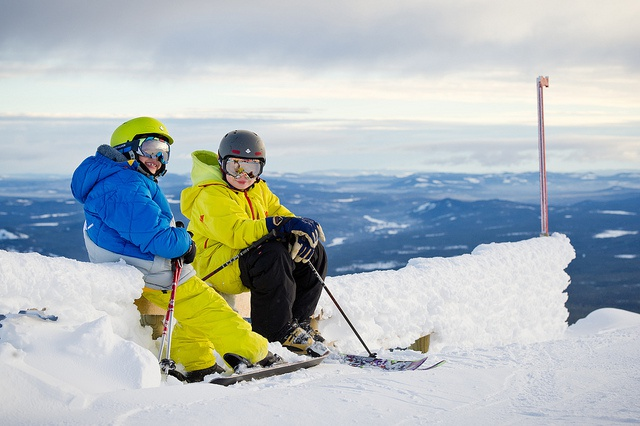Describe the objects in this image and their specific colors. I can see people in gray, blue, olive, gold, and darkgray tones, people in gray, black, gold, and olive tones, and skis in gray, lightgray, darkgray, and black tones in this image. 